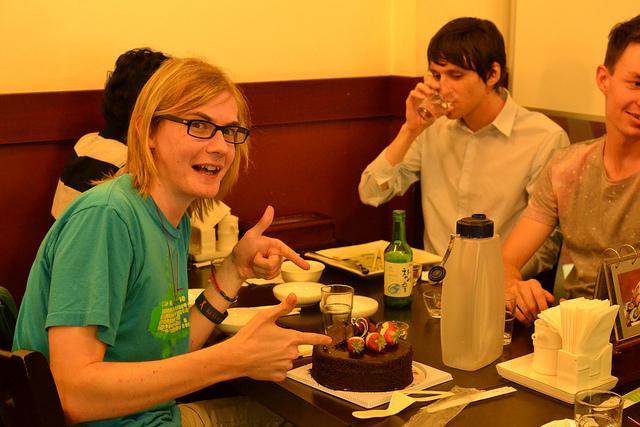How many people are in the shot?
Quick response, please. 4. Where are the strawberries?
Quick response, please. On cake. What meal are they having?
Keep it brief. Dinner. 